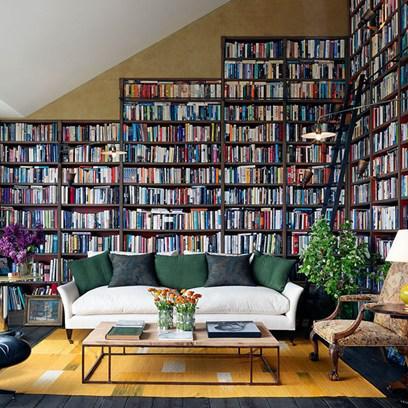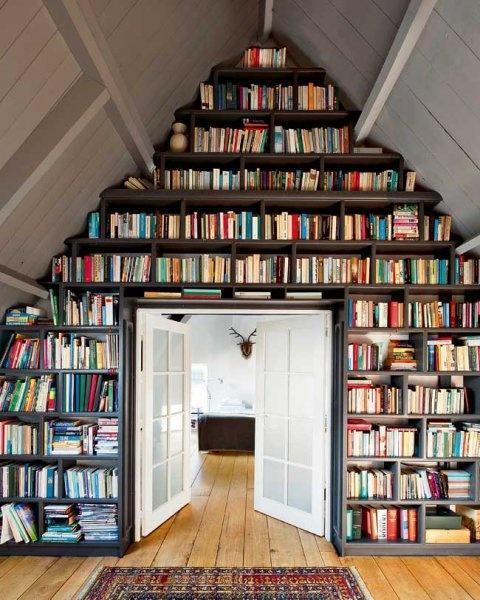The first image is the image on the left, the second image is the image on the right. Assess this claim about the two images: "In one image, a couch with throw pillows, a coffee table and at least one side chair form a seating area in front of a wall of bookshelves.". Correct or not? Answer yes or no. Yes. The first image is the image on the left, the second image is the image on the right. Considering the images on both sides, is "An image shows a square skylight in the peaked ceiling of a room with shelves along the wall." valid? Answer yes or no. No. 